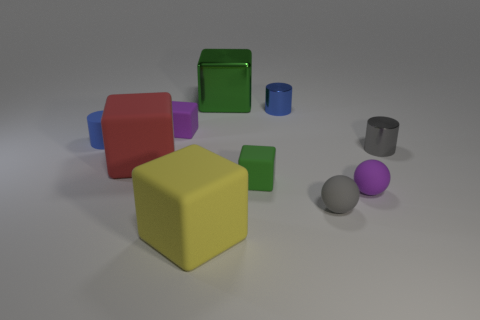Subtract all small blue metal cylinders. How many cylinders are left? 2 Subtract all gray cylinders. How many cylinders are left? 2 Subtract 1 balls. How many balls are left? 1 Subtract all cylinders. How many objects are left? 7 Subtract 0 brown blocks. How many objects are left? 10 Subtract all gray cylinders. Subtract all cyan cubes. How many cylinders are left? 2 Subtract all red cubes. How many brown balls are left? 0 Subtract all brown cylinders. Subtract all small blue rubber things. How many objects are left? 9 Add 2 big green metallic things. How many big green metallic things are left? 3 Add 8 big rubber cubes. How many big rubber cubes exist? 10 